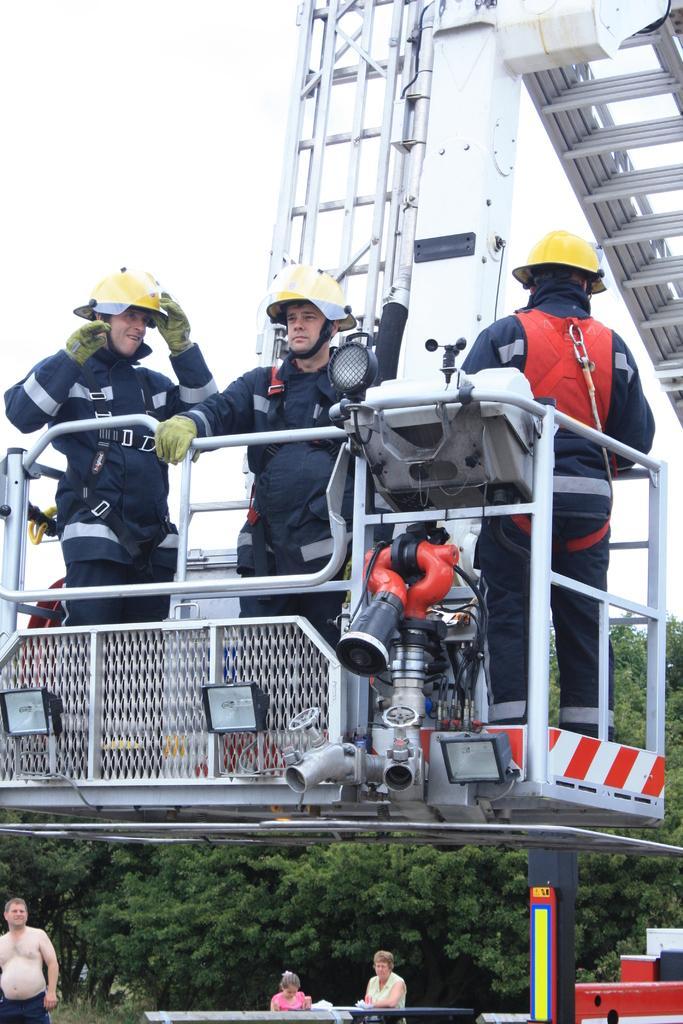Describe this image in one or two sentences. In this image there are three persons are standing on the crane board as we can see in middle of this image and there is a crane board which is in white color and there are some trees at bottom of this image and there are two persons are standing at bottom of this image and the person is at bottom left corner of this image , and there is a sky at top of this image. 